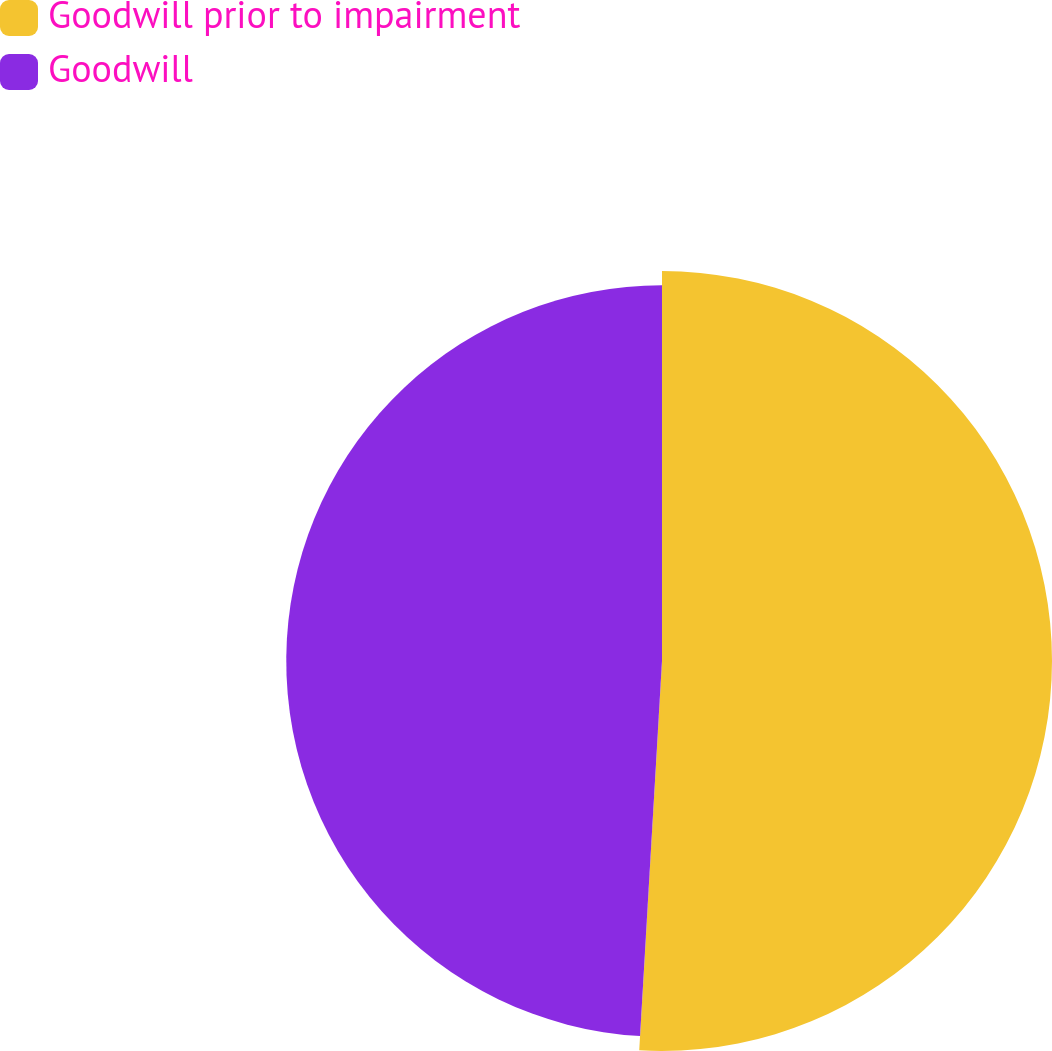Convert chart. <chart><loc_0><loc_0><loc_500><loc_500><pie_chart><fcel>Goodwill prior to impairment<fcel>Goodwill<nl><fcel>50.93%<fcel>49.07%<nl></chart> 